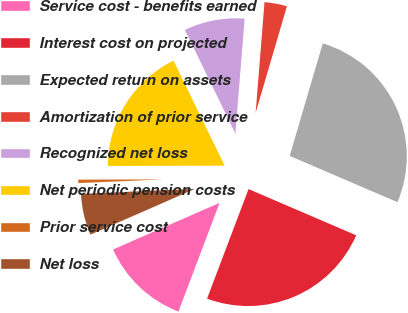<chart> <loc_0><loc_0><loc_500><loc_500><pie_chart><fcel>Service cost - benefits earned<fcel>Interest cost on projected<fcel>Expected return on assets<fcel>Amortization of prior service<fcel>Recognized net loss<fcel>Net periodic pension costs<fcel>Prior service cost<fcel>Net loss<nl><fcel>12.67%<fcel>24.3%<fcel>26.91%<fcel>3.27%<fcel>8.48%<fcel>17.83%<fcel>0.66%<fcel>5.87%<nl></chart> 